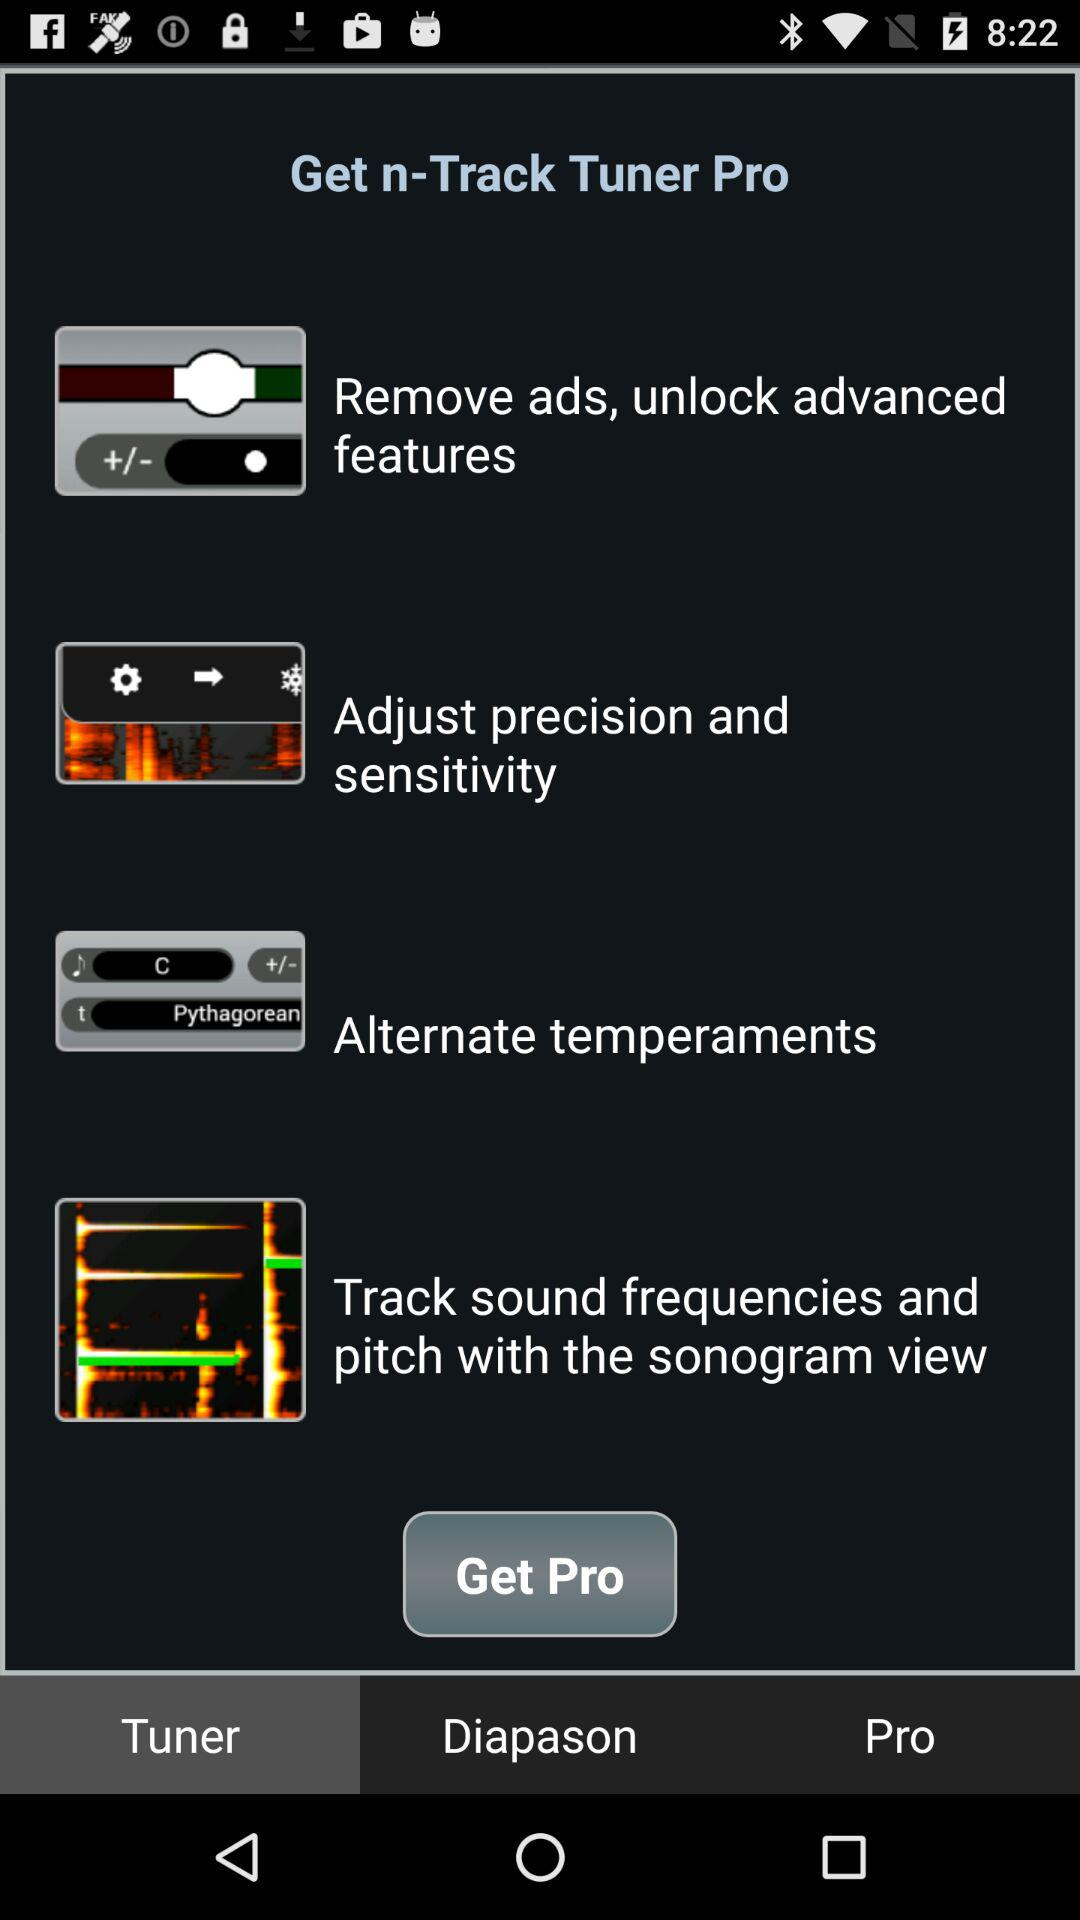What is the selected tab? The selected tab is "Tuner". 